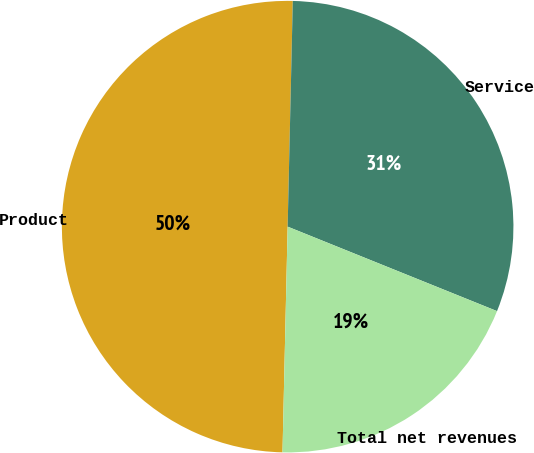Convert chart. <chart><loc_0><loc_0><loc_500><loc_500><pie_chart><fcel>Product<fcel>Service<fcel>Total net revenues<nl><fcel>50.0%<fcel>30.74%<fcel>19.26%<nl></chart> 